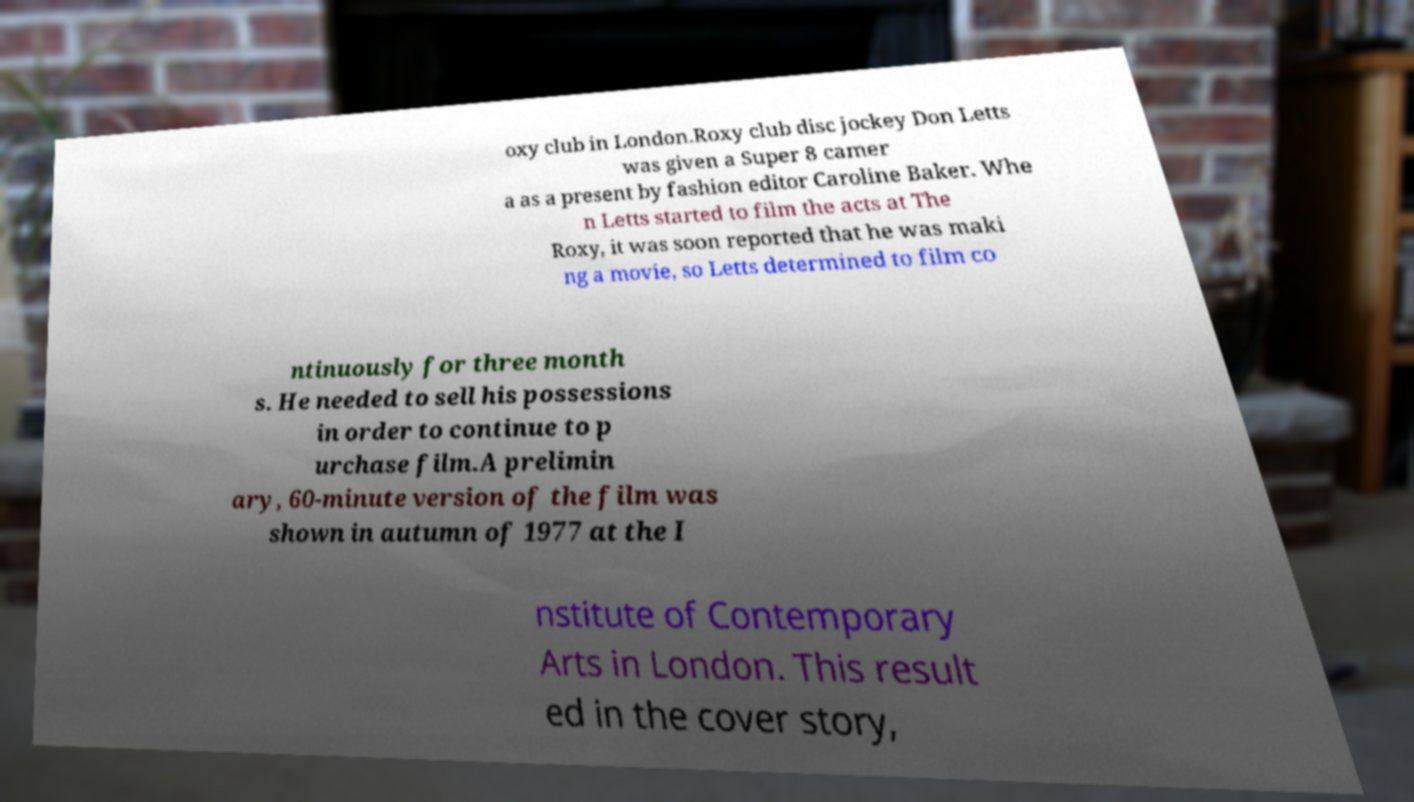Please identify and transcribe the text found in this image. oxy club in London.Roxy club disc jockey Don Letts was given a Super 8 camer a as a present by fashion editor Caroline Baker. Whe n Letts started to film the acts at The Roxy, it was soon reported that he was maki ng a movie, so Letts determined to film co ntinuously for three month s. He needed to sell his possessions in order to continue to p urchase film.A prelimin ary, 60-minute version of the film was shown in autumn of 1977 at the I nstitute of Contemporary Arts in London. This result ed in the cover story, 